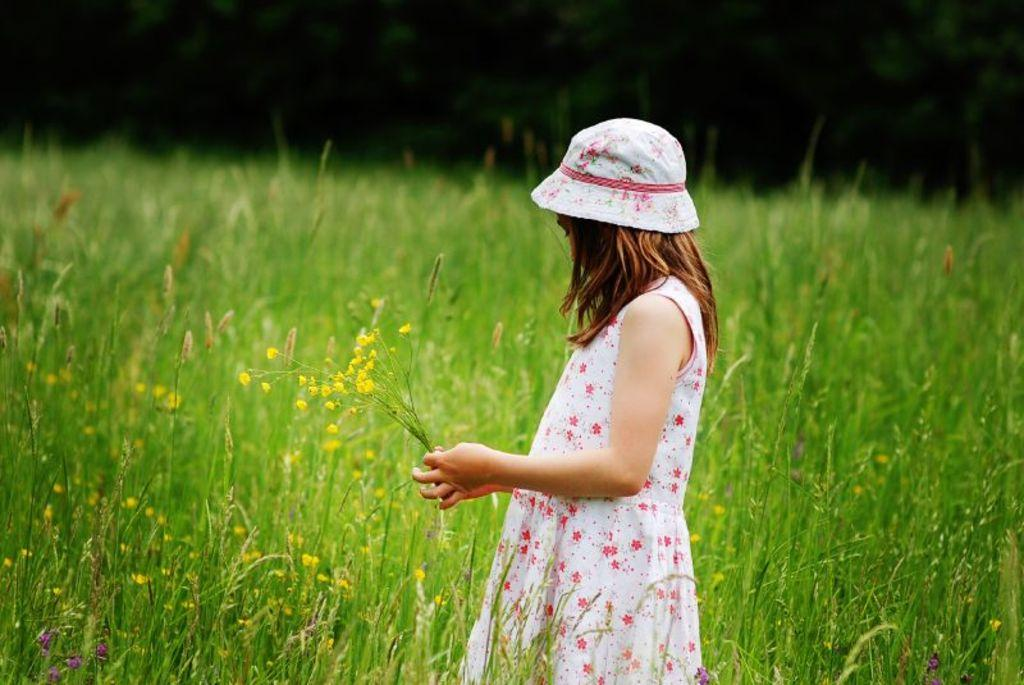Who is present in the image? There is a girl in the image. What is the girl wearing on her head? The girl is wearing a hat. What type of living organisms can be seen in the image? There are plants in the image. What type of curve can be seen in the image? There is no curve present in the image. What type of rhythm is the girl dancing to in the image? There is no dancing or rhythm present in the image. What type of flight is the girl taking in the image? There is no flight or indication of flying in the image. 